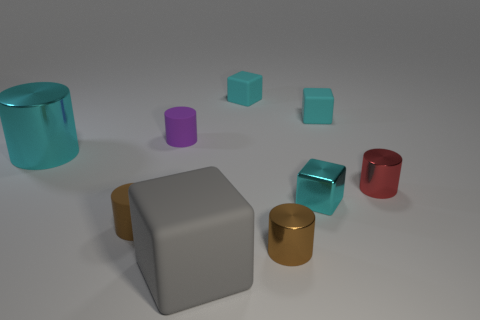Does the large metal object have the same shape as the big rubber thing?
Provide a short and direct response. No. There is a brown cylinder on the left side of the gray matte thing that is in front of the big cyan shiny thing; what is its material?
Provide a succinct answer. Rubber. There is a cylinder that is the same color as the shiny cube; what is it made of?
Give a very brief answer. Metal. Is the size of the shiny block the same as the brown matte cylinder?
Give a very brief answer. Yes. Is there a large rubber object that is behind the red thing that is in front of the tiny purple thing?
Give a very brief answer. No. What size is the shiny thing that is the same color as the small metal block?
Offer a very short reply. Large. The small cyan object in front of the red cylinder has what shape?
Keep it short and to the point. Cube. How many small brown cylinders are left of the small brown metallic thing in front of the metallic cylinder behind the red shiny thing?
Provide a short and direct response. 1. Does the brown rubber thing have the same size as the matte object to the right of the tiny cyan metal block?
Ensure brevity in your answer.  Yes. There is a cyan shiny object behind the cyan metallic object that is right of the big cyan cylinder; how big is it?
Keep it short and to the point. Large. 